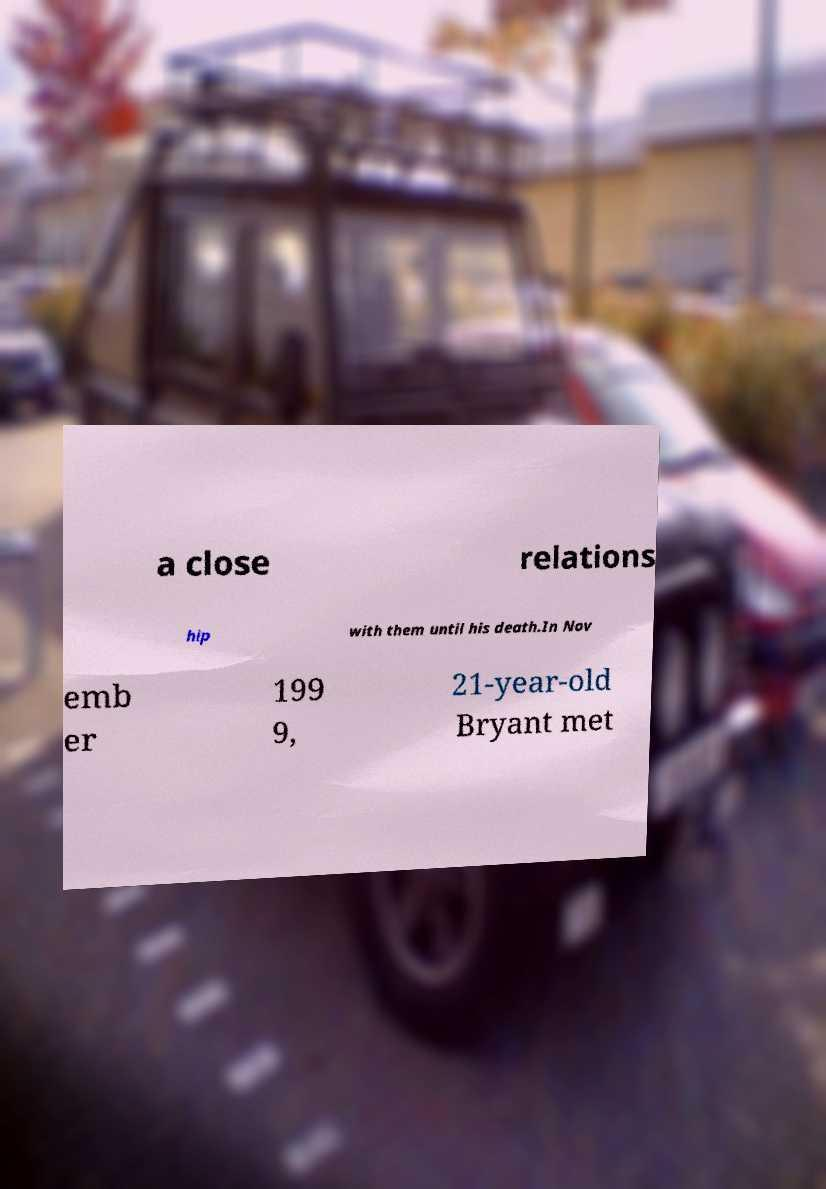Please read and relay the text visible in this image. What does it say? a close relations hip with them until his death.In Nov emb er 199 9, 21-year-old Bryant met 